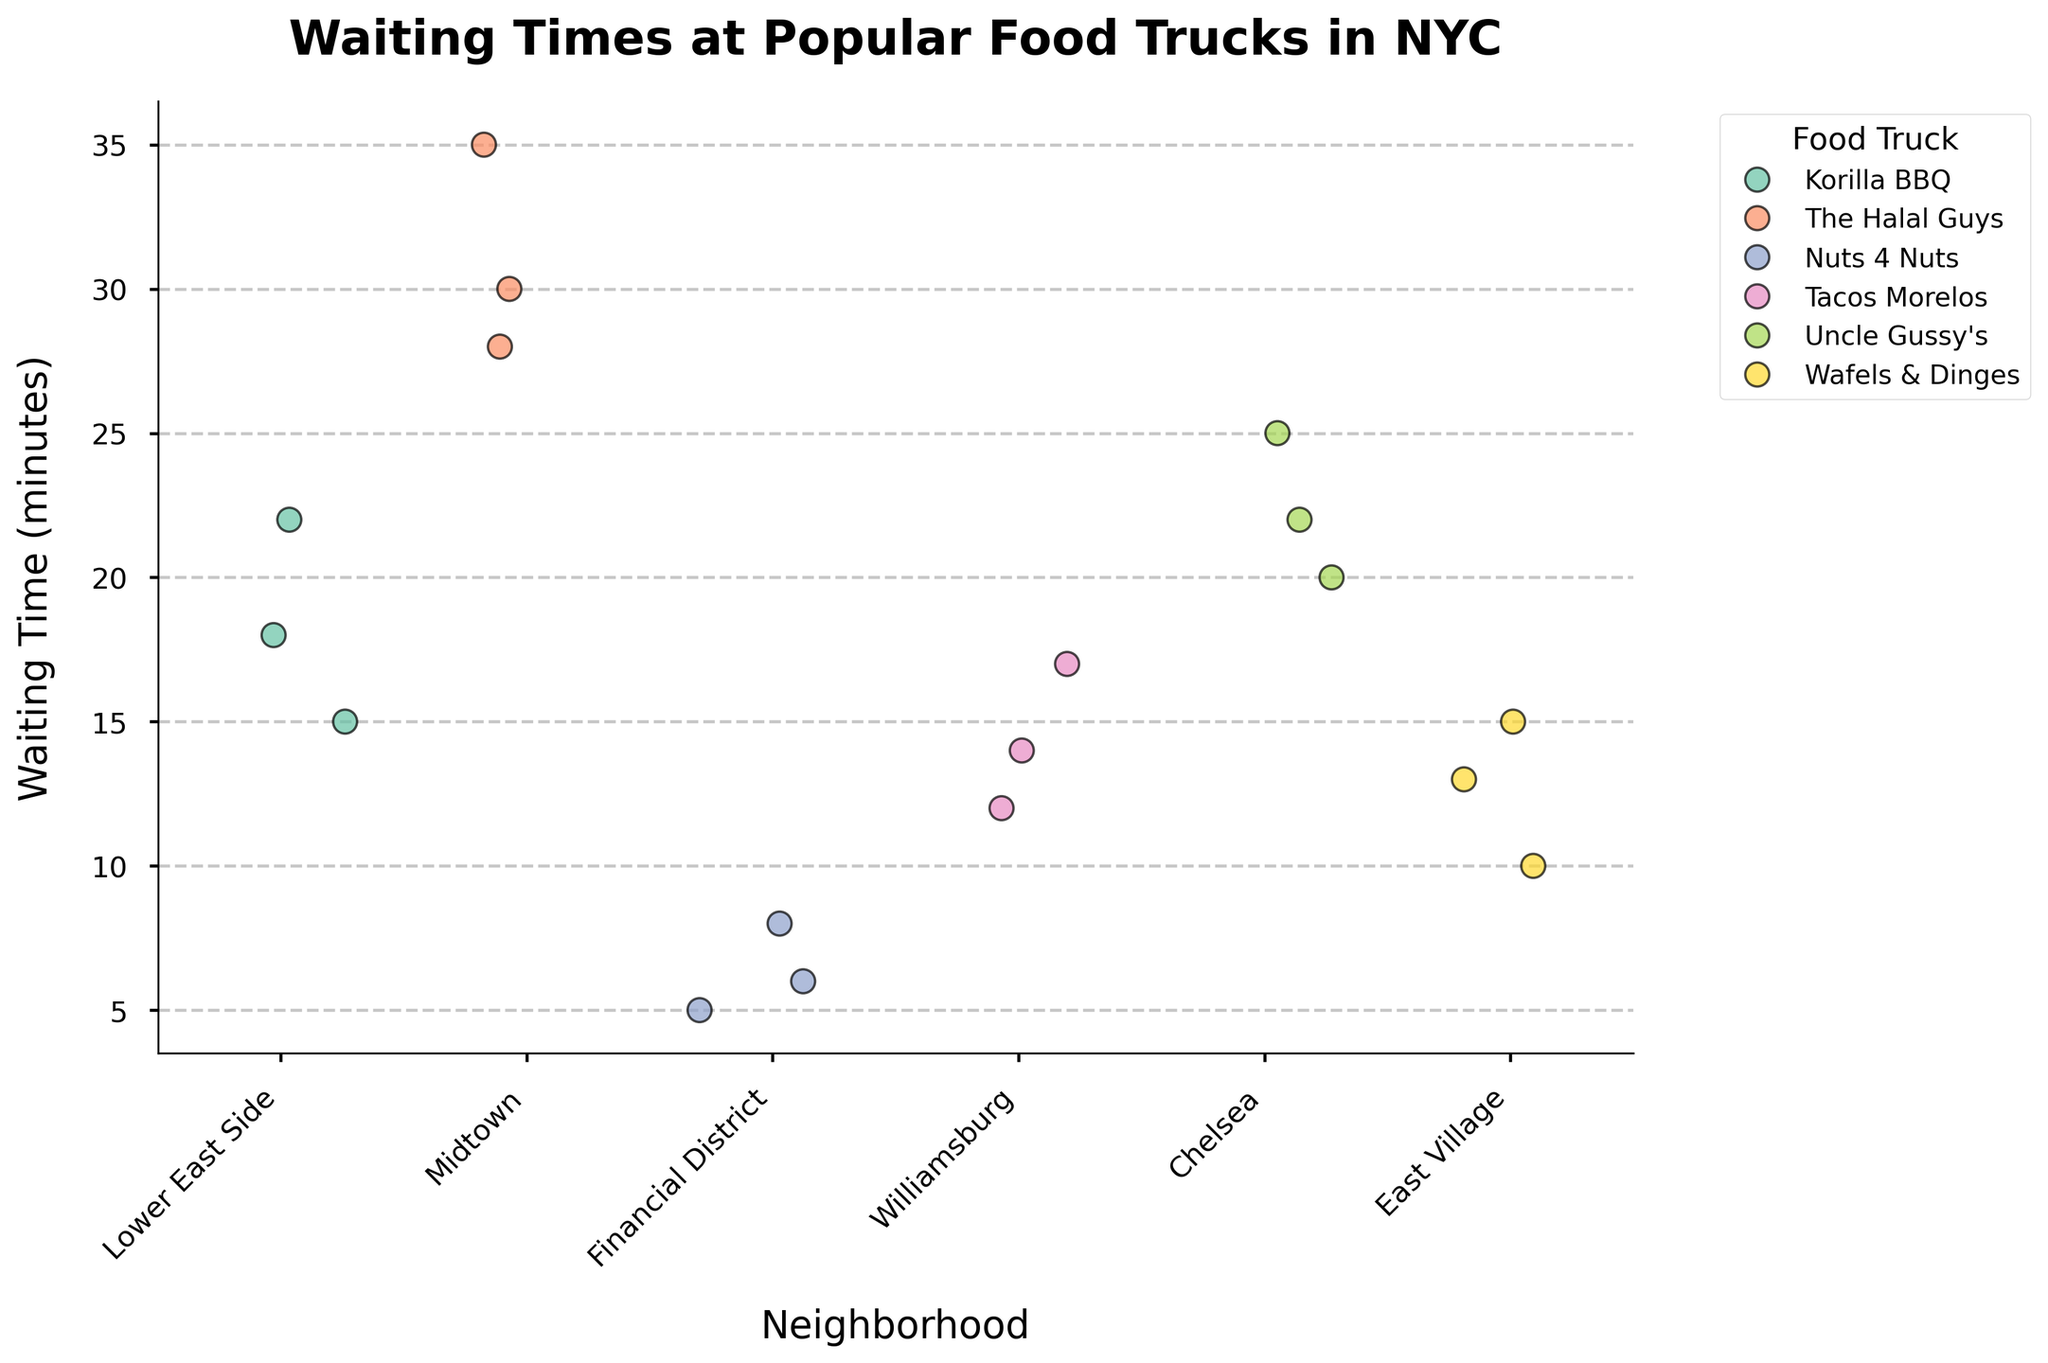Which neighborhood has the longest range of waiting times for a single food truck? Look for the neighborhood where the waiting times for a single food truck span the widest range (difference between the maximum and minimum values). In Midtown at "The Halal Guys", the waiting times range from 28 to 35 minutes, making it the longest range.
Answer: Midtown What is the average waiting time for "Korilla BBQ" on the Lower East Side? Add up the waiting times (15, 22, and 18) for "Korilla BBQ" on the Lower East Side and then divide by the number of data points (3). The sum is 55, and 55/3 gives an average of approximately 18.33 minutes.
Answer: 18.33 minutes Do any neighborhoods have food trucks with waiting times less than 10 minutes? Scan for waiting times below 10 minutes across different neighborhoods. In the Financial District, "Nuts 4 Nuts" has waiting times of 5, 6, and 8 minutes, all under 10 minutes.
Answer: Yes, Financial District Which food truck has the longest average waiting time overall? Calculate the average waiting times for each food truck and compare them. "The Halal Guys" has waiting times of 30, 35, and 28 minutes; the average is (30 + 35 + 28)/3 = 31 minutes, the highest among all food trucks.
Answer: The Halal Guys How does the waiting time at "Wafels & Dinges" in the East Village compare to "Nuts 4 Nuts" in the Financial District? Compare the waiting times for "Wafels & Dinges" (10, 15, 13) to "Nuts 4 Nuts" (5, 8, 6). The average for "Wafels & Dinges" is (10 + 15 + 13)/3 ≈ 12.67 minutes and for "Nuts 4 Nuts" is (5 + 8 + 6)/3 ≈ 6.33 minutes. "Wafels & Dinges" has longer waiting times.
Answer: Wafels & Dinges has longer waiting times Which food truck in Chelsea has the longest waiting time? Look at the waiting times for "Uncle Gussy's" in Chelsea, which are 20, 25, and 22 minutes. The longest waiting time is 25 minutes.
Answer: Uncle Gussy's with 25 minutes What is the median waiting time for "Tacos Morelos" in Williamsburg? Arrange the waiting times (12, 14, 17) for "Tacos Morelos" in ascending order. The middle value is 14, which is the median waiting time.
Answer: 14 minutes How do the waiting times for "Korilla BBQ" on the Lower East Side compare to "Uncle Gussy's" in Chelsea? Compare waiting times for "Korilla BBQ" (15, 22, 18) to "Uncle Gussy's" (20, 25, 22). Both sets of waiting times are close, but "Uncle Gussy's" has slightly higher values on average.
Answer: Uncle Gussy's in Chelsea has higher waiting times What is the total number of waiting time data points displayed in the plot? Count all the waiting time values across all neighborhoods and food trucks. There are 3 values each for 6 food trucks, making a total of 18 data points.
Answer: 18 data points Is the waiting time distribution for "The Halal Guys" in Midtown skewed or symmetric? Check the distribution of waiting times for skewness or symmetry. The values are 30, 35, and 28 minutes, which shows a symmetric distribution centered around a typical waiting time.
Answer: Symmetric 